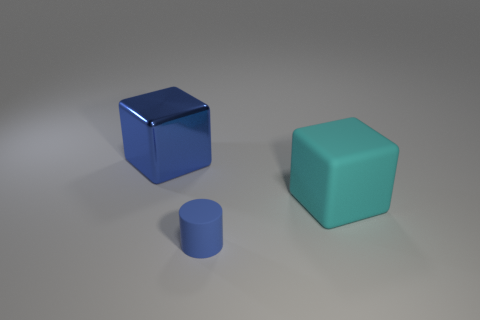There is a big thing that is right of the matte cylinder; what is its material?
Your answer should be very brief. Rubber. Are there an equal number of small blue rubber cylinders that are behind the big blue object and matte objects behind the blue rubber object?
Offer a very short reply. No. The other metallic thing that is the same shape as the cyan object is what color?
Provide a short and direct response. Blue. Is there anything else that is the same color as the large rubber object?
Provide a short and direct response. No. How many metallic things are cylinders or cubes?
Offer a very short reply. 1. Is the color of the big shiny thing the same as the tiny rubber cylinder?
Your response must be concise. Yes. Is the number of tiny things that are in front of the cyan object greater than the number of big green spheres?
Your answer should be compact. Yes. What number of other objects are there of the same material as the cyan block?
Ensure brevity in your answer.  1. How many small things are blue matte objects or cyan rubber balls?
Provide a short and direct response. 1. Is the material of the blue cylinder the same as the cyan thing?
Your answer should be compact. Yes. 